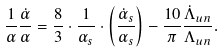<formula> <loc_0><loc_0><loc_500><loc_500>\frac { 1 } { \alpha } \frac { \dot { \alpha } } { \alpha } = \frac { 8 } { 3 } \cdot \frac { 1 } { \alpha _ { s } } \cdot \left ( \frac { \dot { \alpha } _ { s } } { \alpha _ { s } } \right ) - \frac { 1 0 } { \pi } \frac { \dot { \Lambda } _ { u n } } { \Lambda _ { u n } } .</formula> 